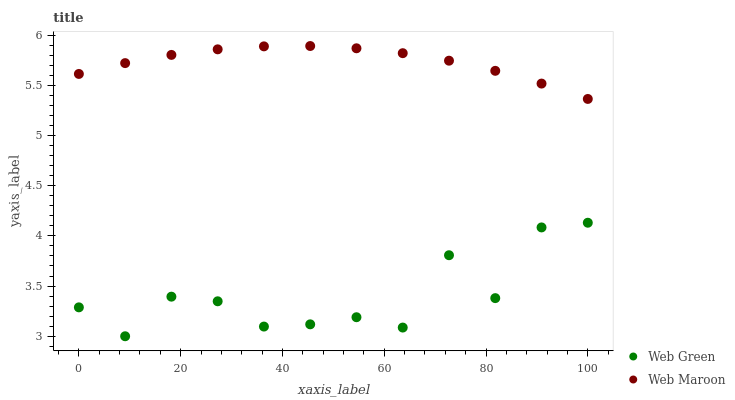Does Web Green have the minimum area under the curve?
Answer yes or no. Yes. Does Web Maroon have the maximum area under the curve?
Answer yes or no. Yes. Does Web Green have the maximum area under the curve?
Answer yes or no. No. Is Web Maroon the smoothest?
Answer yes or no. Yes. Is Web Green the roughest?
Answer yes or no. Yes. Is Web Green the smoothest?
Answer yes or no. No. Does Web Green have the lowest value?
Answer yes or no. Yes. Does Web Maroon have the highest value?
Answer yes or no. Yes. Does Web Green have the highest value?
Answer yes or no. No. Is Web Green less than Web Maroon?
Answer yes or no. Yes. Is Web Maroon greater than Web Green?
Answer yes or no. Yes. Does Web Green intersect Web Maroon?
Answer yes or no. No. 